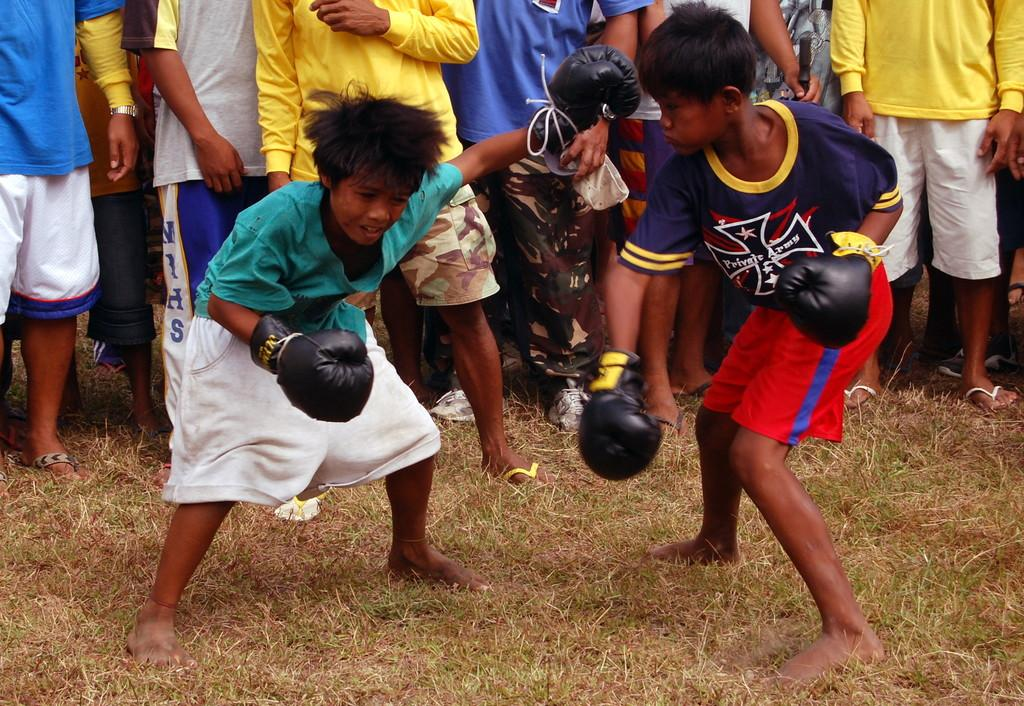How many kids are in the image? There are two kids in the image. What activity are the kids participating in? The kids are participating in boxing. Can you describe the people in the background of the image? The people in the background are watching the kids. What type of weather can be seen in the image? The provided facts do not mention any weather conditions, so it cannot be determined from the image. 